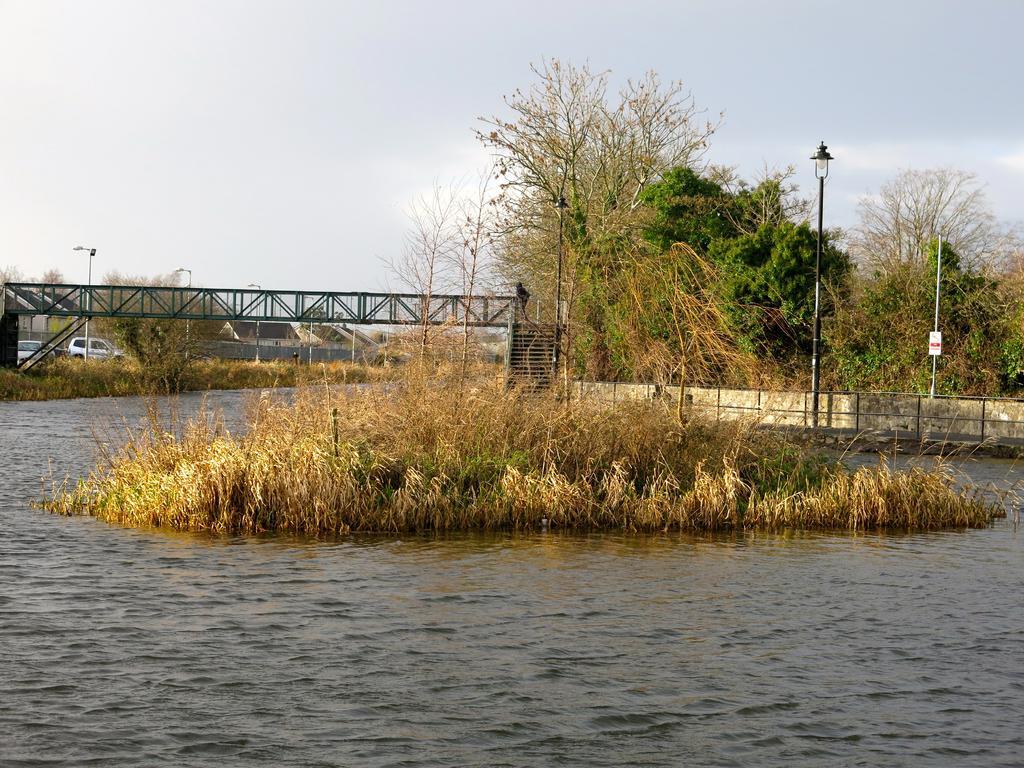Could you give a brief overview of what you see in this image? This picture is taken near the lake where there are trees and a bridge and where there are some houses surrounded by the trees and there are two cars on the road and in the middle of the water there is one small grassland is present. 